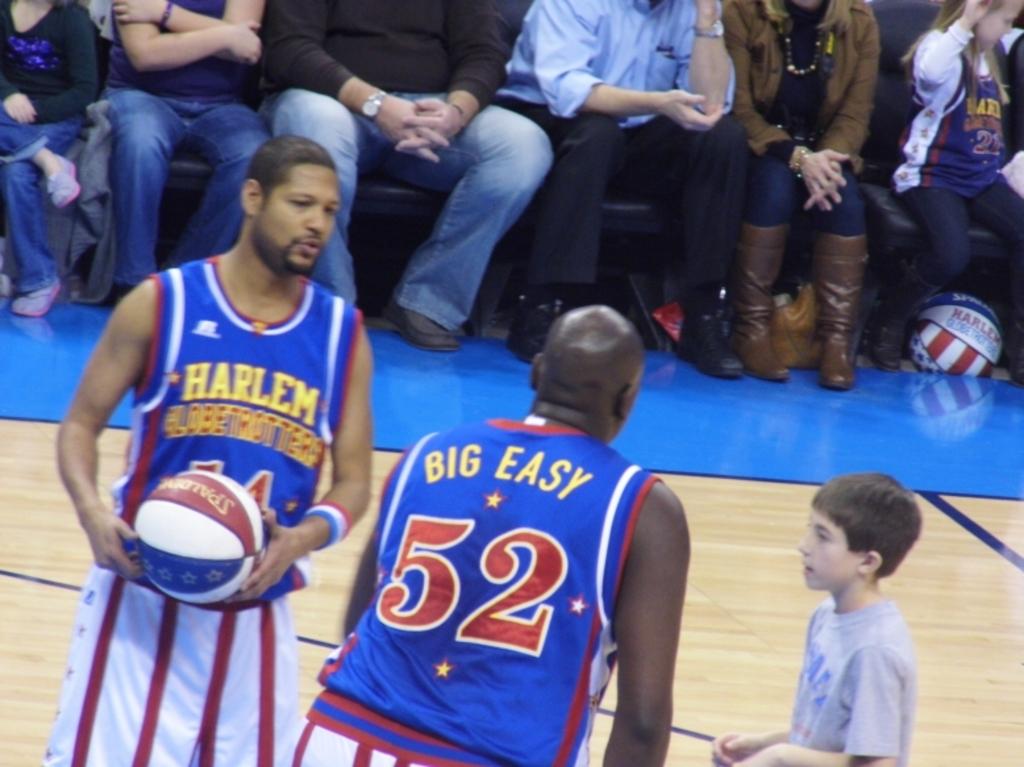What is big easy's number?
Provide a succinct answer. 52. 